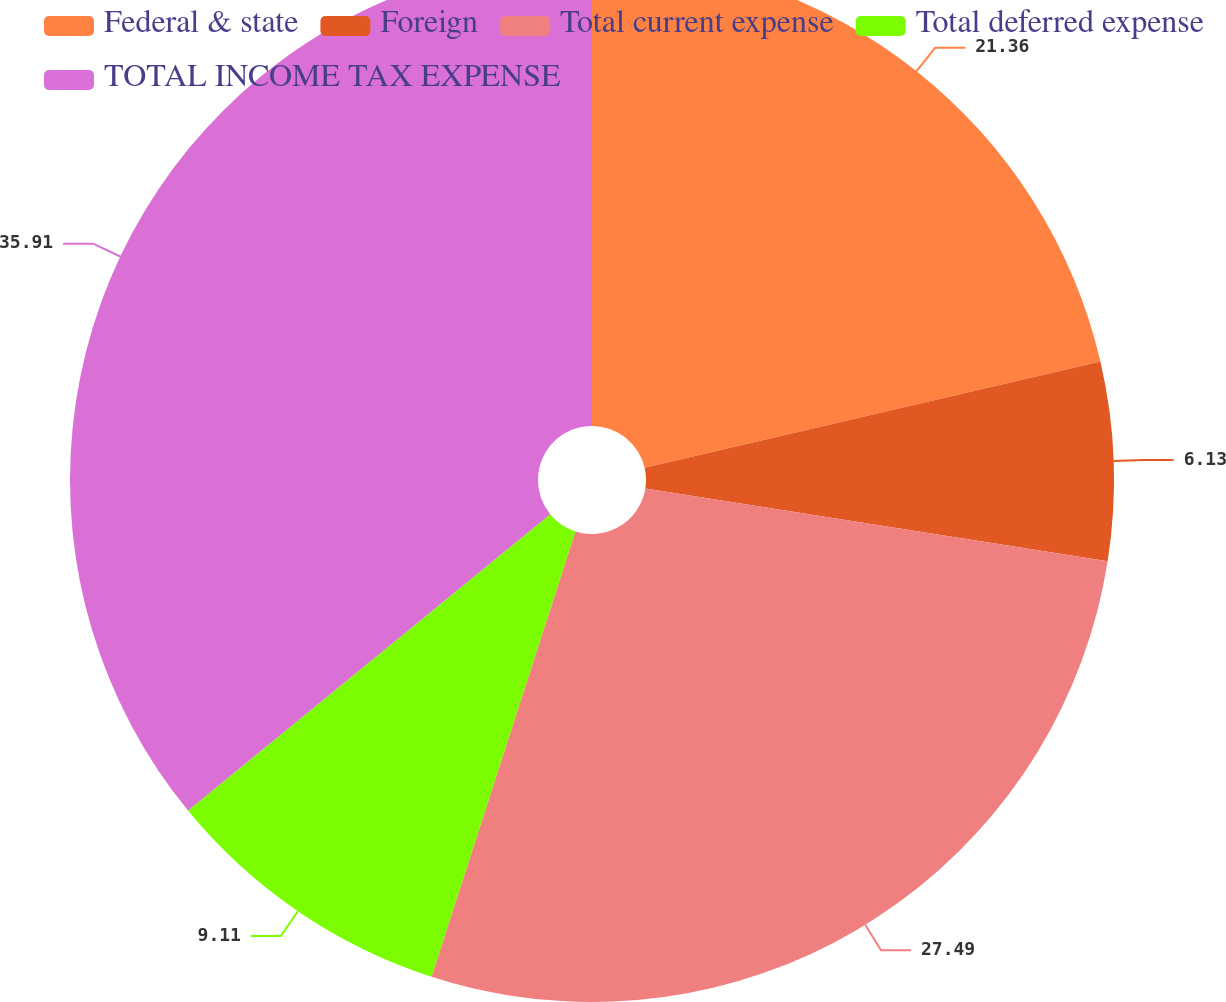<chart> <loc_0><loc_0><loc_500><loc_500><pie_chart><fcel>Federal & state<fcel>Foreign<fcel>Total current expense<fcel>Total deferred expense<fcel>TOTAL INCOME TAX EXPENSE<nl><fcel>21.36%<fcel>6.13%<fcel>27.49%<fcel>9.11%<fcel>35.92%<nl></chart> 